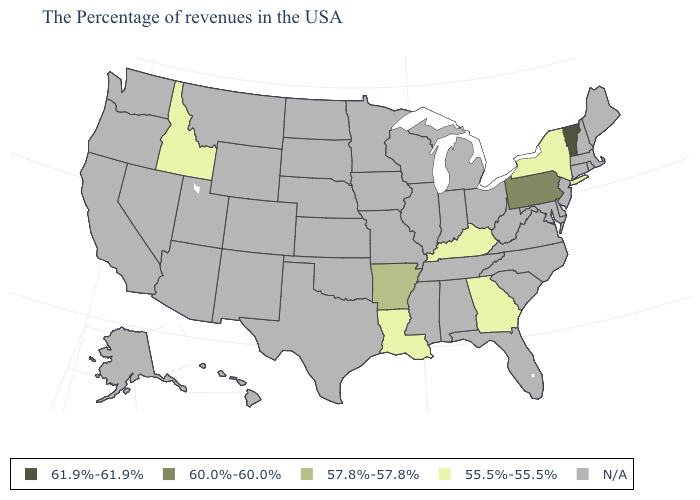Name the states that have a value in the range 55.5%-55.5%?
Write a very short answer. New York, Georgia, Kentucky, Louisiana, Idaho. What is the value of Indiana?
Answer briefly. N/A. What is the lowest value in the West?
Concise answer only. 55.5%-55.5%. What is the value of Indiana?
Keep it brief. N/A. What is the value of Arkansas?
Keep it brief. 57.8%-57.8%. What is the value of Florida?
Quick response, please. N/A. Name the states that have a value in the range 55.5%-55.5%?
Be succinct. New York, Georgia, Kentucky, Louisiana, Idaho. Does Arkansas have the highest value in the USA?
Give a very brief answer. No. Name the states that have a value in the range N/A?
Short answer required. Maine, Massachusetts, Rhode Island, New Hampshire, Connecticut, New Jersey, Delaware, Maryland, Virginia, North Carolina, South Carolina, West Virginia, Ohio, Florida, Michigan, Indiana, Alabama, Tennessee, Wisconsin, Illinois, Mississippi, Missouri, Minnesota, Iowa, Kansas, Nebraska, Oklahoma, Texas, South Dakota, North Dakota, Wyoming, Colorado, New Mexico, Utah, Montana, Arizona, Nevada, California, Washington, Oregon, Alaska, Hawaii. Which states hav the highest value in the Northeast?
Answer briefly. Vermont. Does the first symbol in the legend represent the smallest category?
Be succinct. No. How many symbols are there in the legend?
Concise answer only. 5. Among the states that border North Carolina , which have the lowest value?
Keep it brief. Georgia. What is the value of Tennessee?
Quick response, please. N/A. 